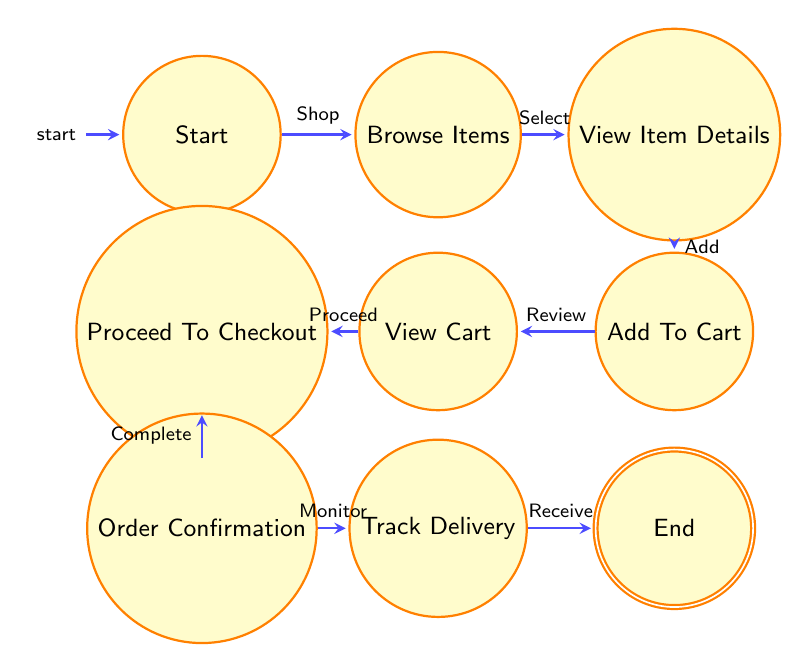What is the starting point of the journey? The diagram indicates that the starting point of the journey is labeled as "Start." This node represents the initial state where the user decides to purchase Hokies women's basketball merchandise.
Answer: Start How many nodes are in the diagram? Counting the nodes represented in the diagram, we find a total of 8 nodes: Start, Browse Items, View Item Details, Add To Cart, View Cart, Proceed To Checkout, Order Confirmation, and Track Delivery.
Answer: 8 What action leads from "View Item Details" to "Add To Cart"? The arrow connecting these two nodes indicates the action taken is "Add." This means after viewing item details, the user adds the selected item to their shopping cart.
Answer: Add What is the last state the user reaches after tracking the delivery? The final state after tracking the delivery is represented as "End." It indicates the conclusion of the user's journey after receiving their merchandise.
Answer: End Which action follows "Order Confirmation" in the flow? From the "Order Confirmation" node, the next action as indicated by the arrow is "Monitor," leading to the "Track Delivery" state where the user can track their order.
Answer: Monitor Is it possible to return to "Browse Items" after viewing the cart? The diagram does not indicate any paths returning to "Browse Items" from "View Cart." Instead, the flow continues from "View Cart" to "Proceed To Checkout."
Answer: No What is the transition from "Add To Cart" to "View Cart"? The transition from "Add To Cart" to "View Cart" signifies the user has chosen the action to "Review" their selected items in the shopping cart.
Answer: Review What comes after "Proceed To Checkout"? The transition following "Proceed To Checkout" is represented by the action "Complete," transitioning to the "Order Confirmation" node where the payment is confirmed.
Answer: Complete 